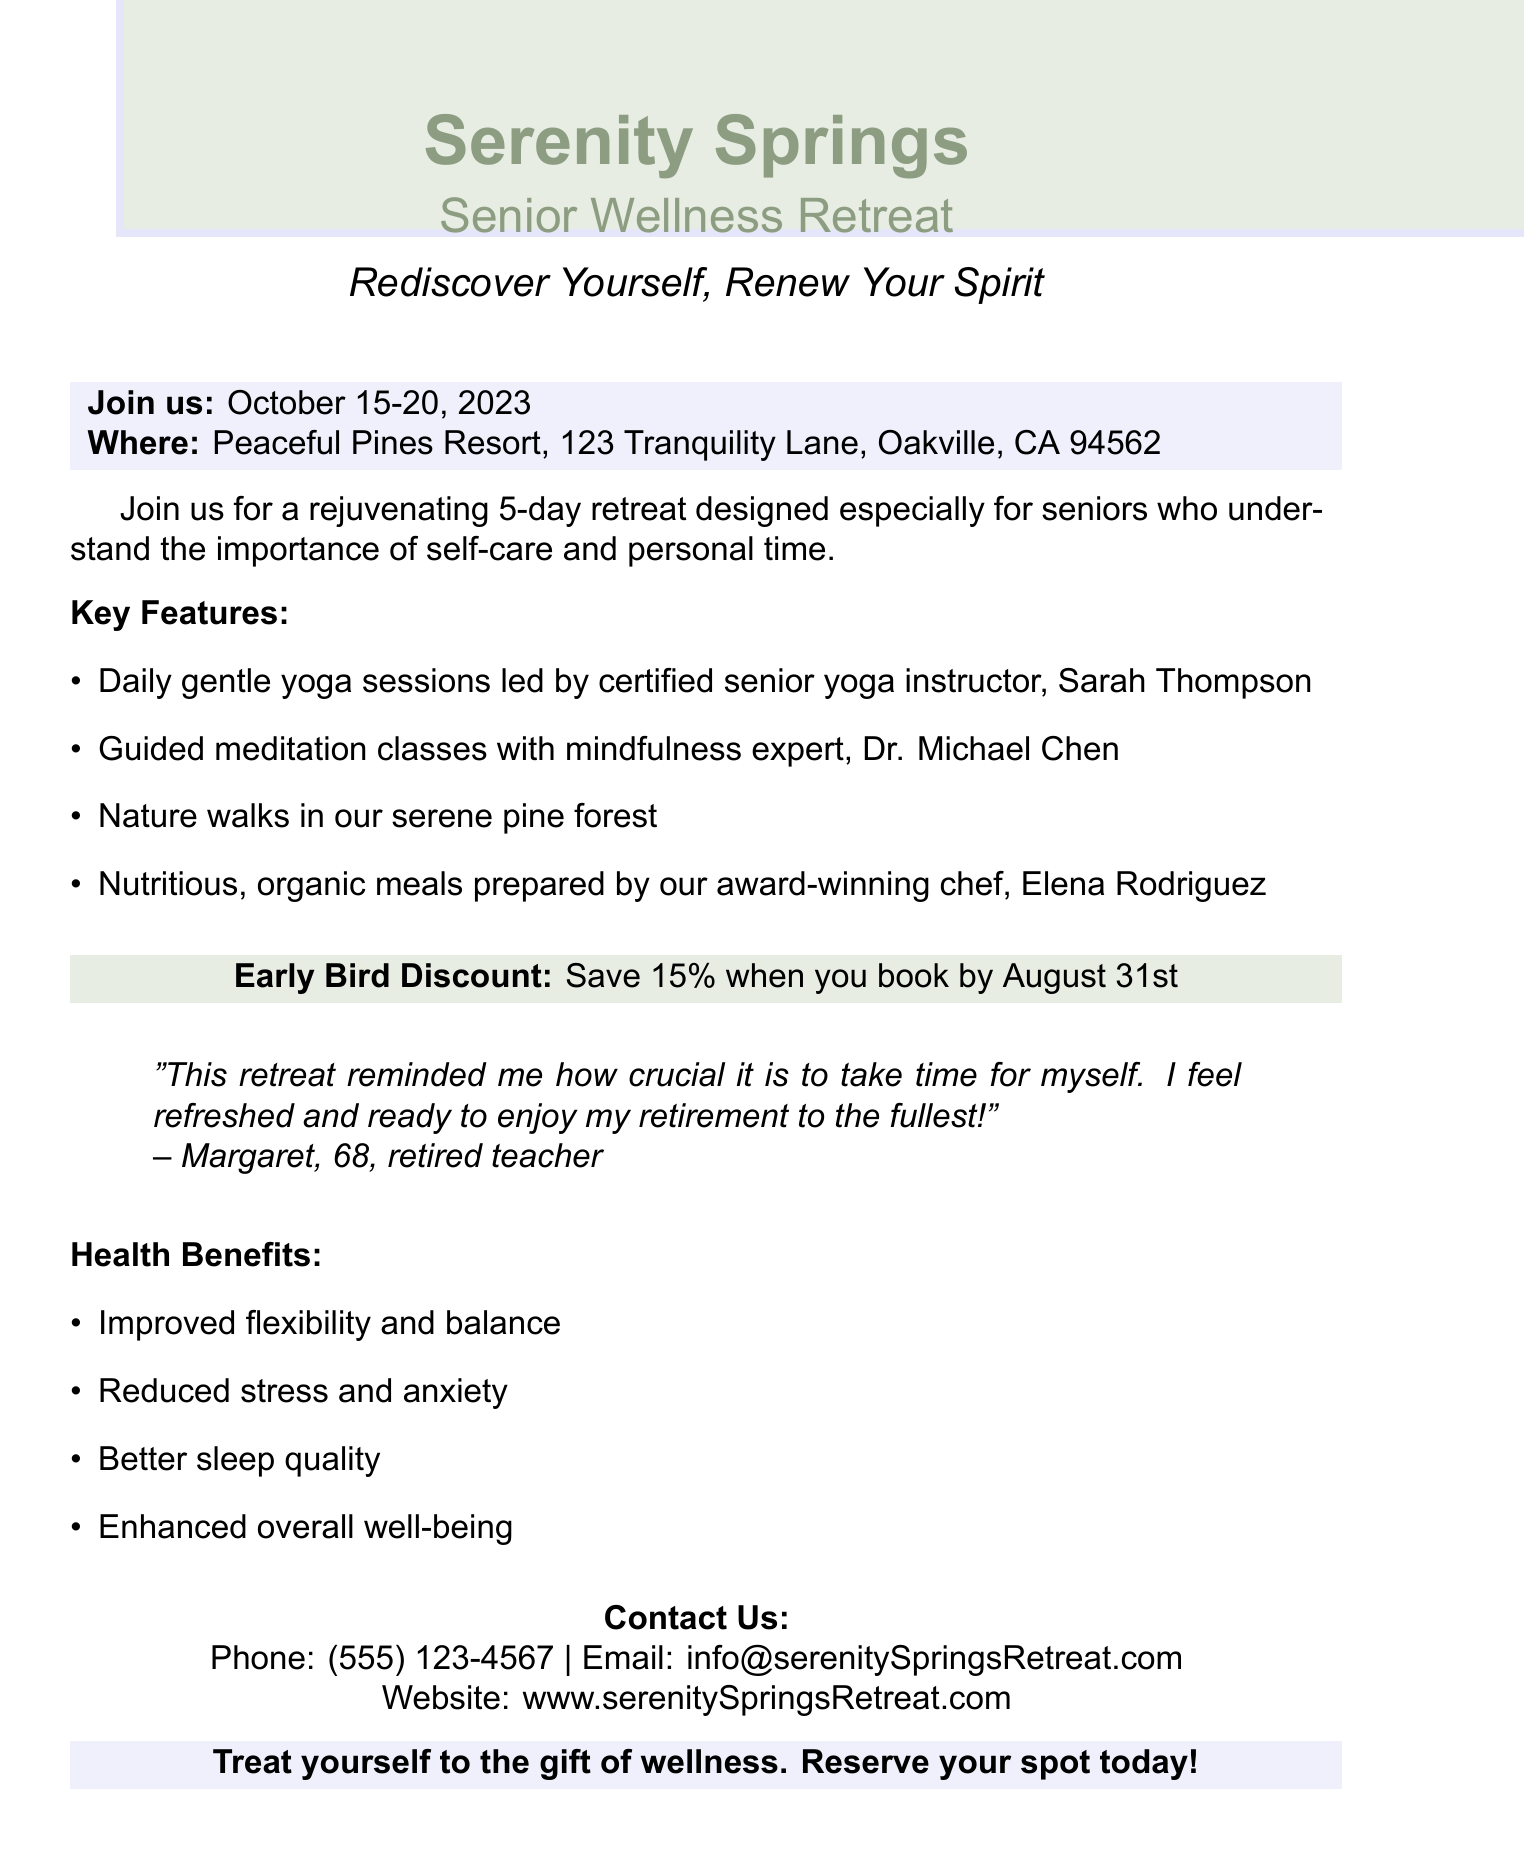What are the dates of the retreat? The document states the retreat dates as October 15-20, 2023.
Answer: October 15-20, 2023 Who leads the yoga sessions? The key features indicate that gentle yoga sessions are led by certified senior yoga instructor, Sarah Thompson.
Answer: Sarah Thompson What is the special offer mentioned? The document includes a special offer for an early bird discount that saves 15% when booked by August 31st.
Answer: Save 15% when you book by August 31st What location is the retreat held at? The location of the retreat is provided as Peaceful Pines Resort, 123 Tranquility Lane, Oakville, CA 94562.
Answer: Peaceful Pines Resort, 123 Tranquility Lane, Oakville, CA 94562 What benefit is related to stress? The health benefits mentioned include reduced stress and anxiety.
Answer: Reduced stress and anxiety How many days does the retreat last? The description states that the retreat is designed for 5 days.
Answer: 5 days What type of meals are provided? The document specifies that the meals are nutritious and organic, prepared by the award-winning chef, Elena Rodriguez.
Answer: Nutritious, organic meals What does the testimonial emphasize? The testimonial highlights the importance of taking time for oneself and feeling refreshed in retirement.
Answer: Importance of taking time for oneself 